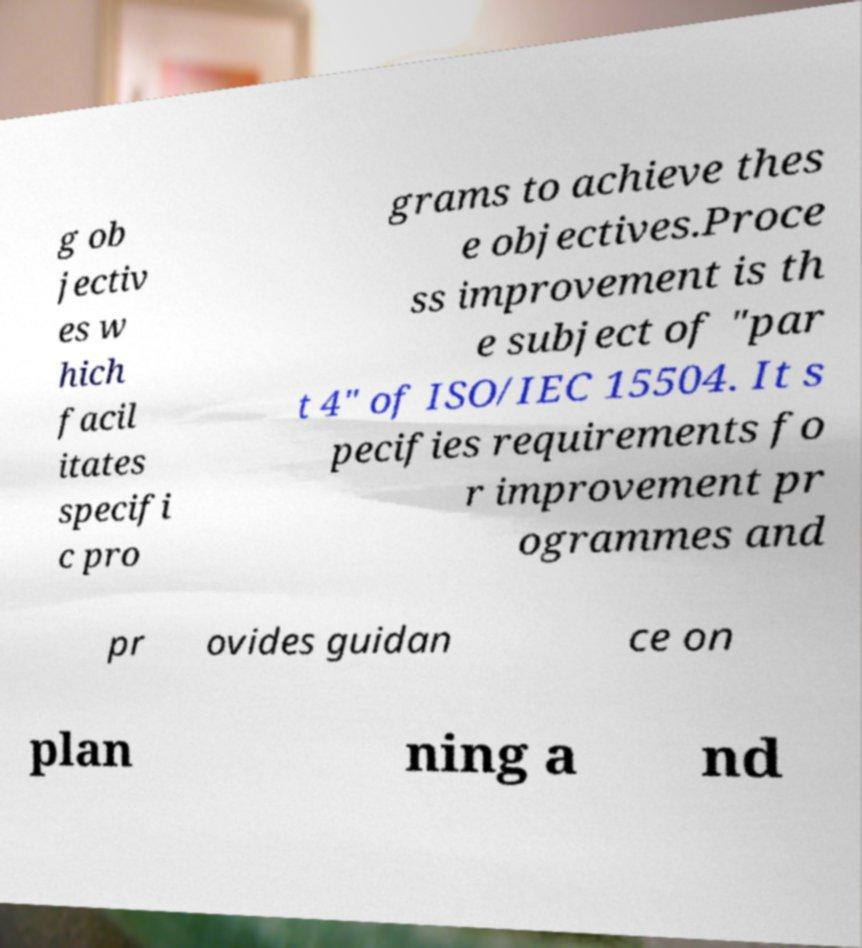What messages or text are displayed in this image? I need them in a readable, typed format. g ob jectiv es w hich facil itates specifi c pro grams to achieve thes e objectives.Proce ss improvement is th e subject of "par t 4" of ISO/IEC 15504. It s pecifies requirements fo r improvement pr ogrammes and pr ovides guidan ce on plan ning a nd 